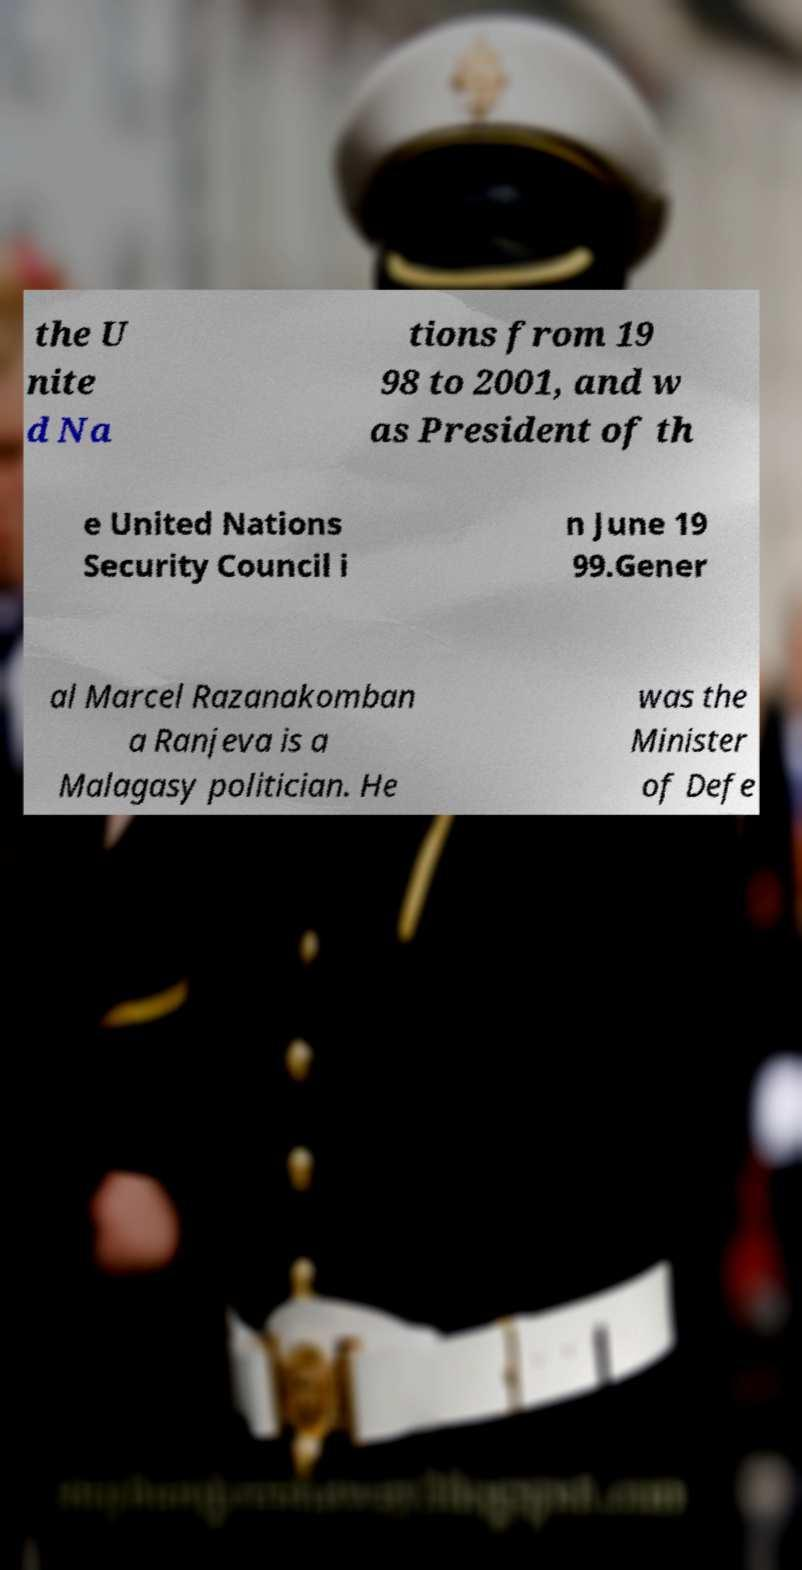I need the written content from this picture converted into text. Can you do that? the U nite d Na tions from 19 98 to 2001, and w as President of th e United Nations Security Council i n June 19 99.Gener al Marcel Razanakomban a Ranjeva is a Malagasy politician. He was the Minister of Defe 